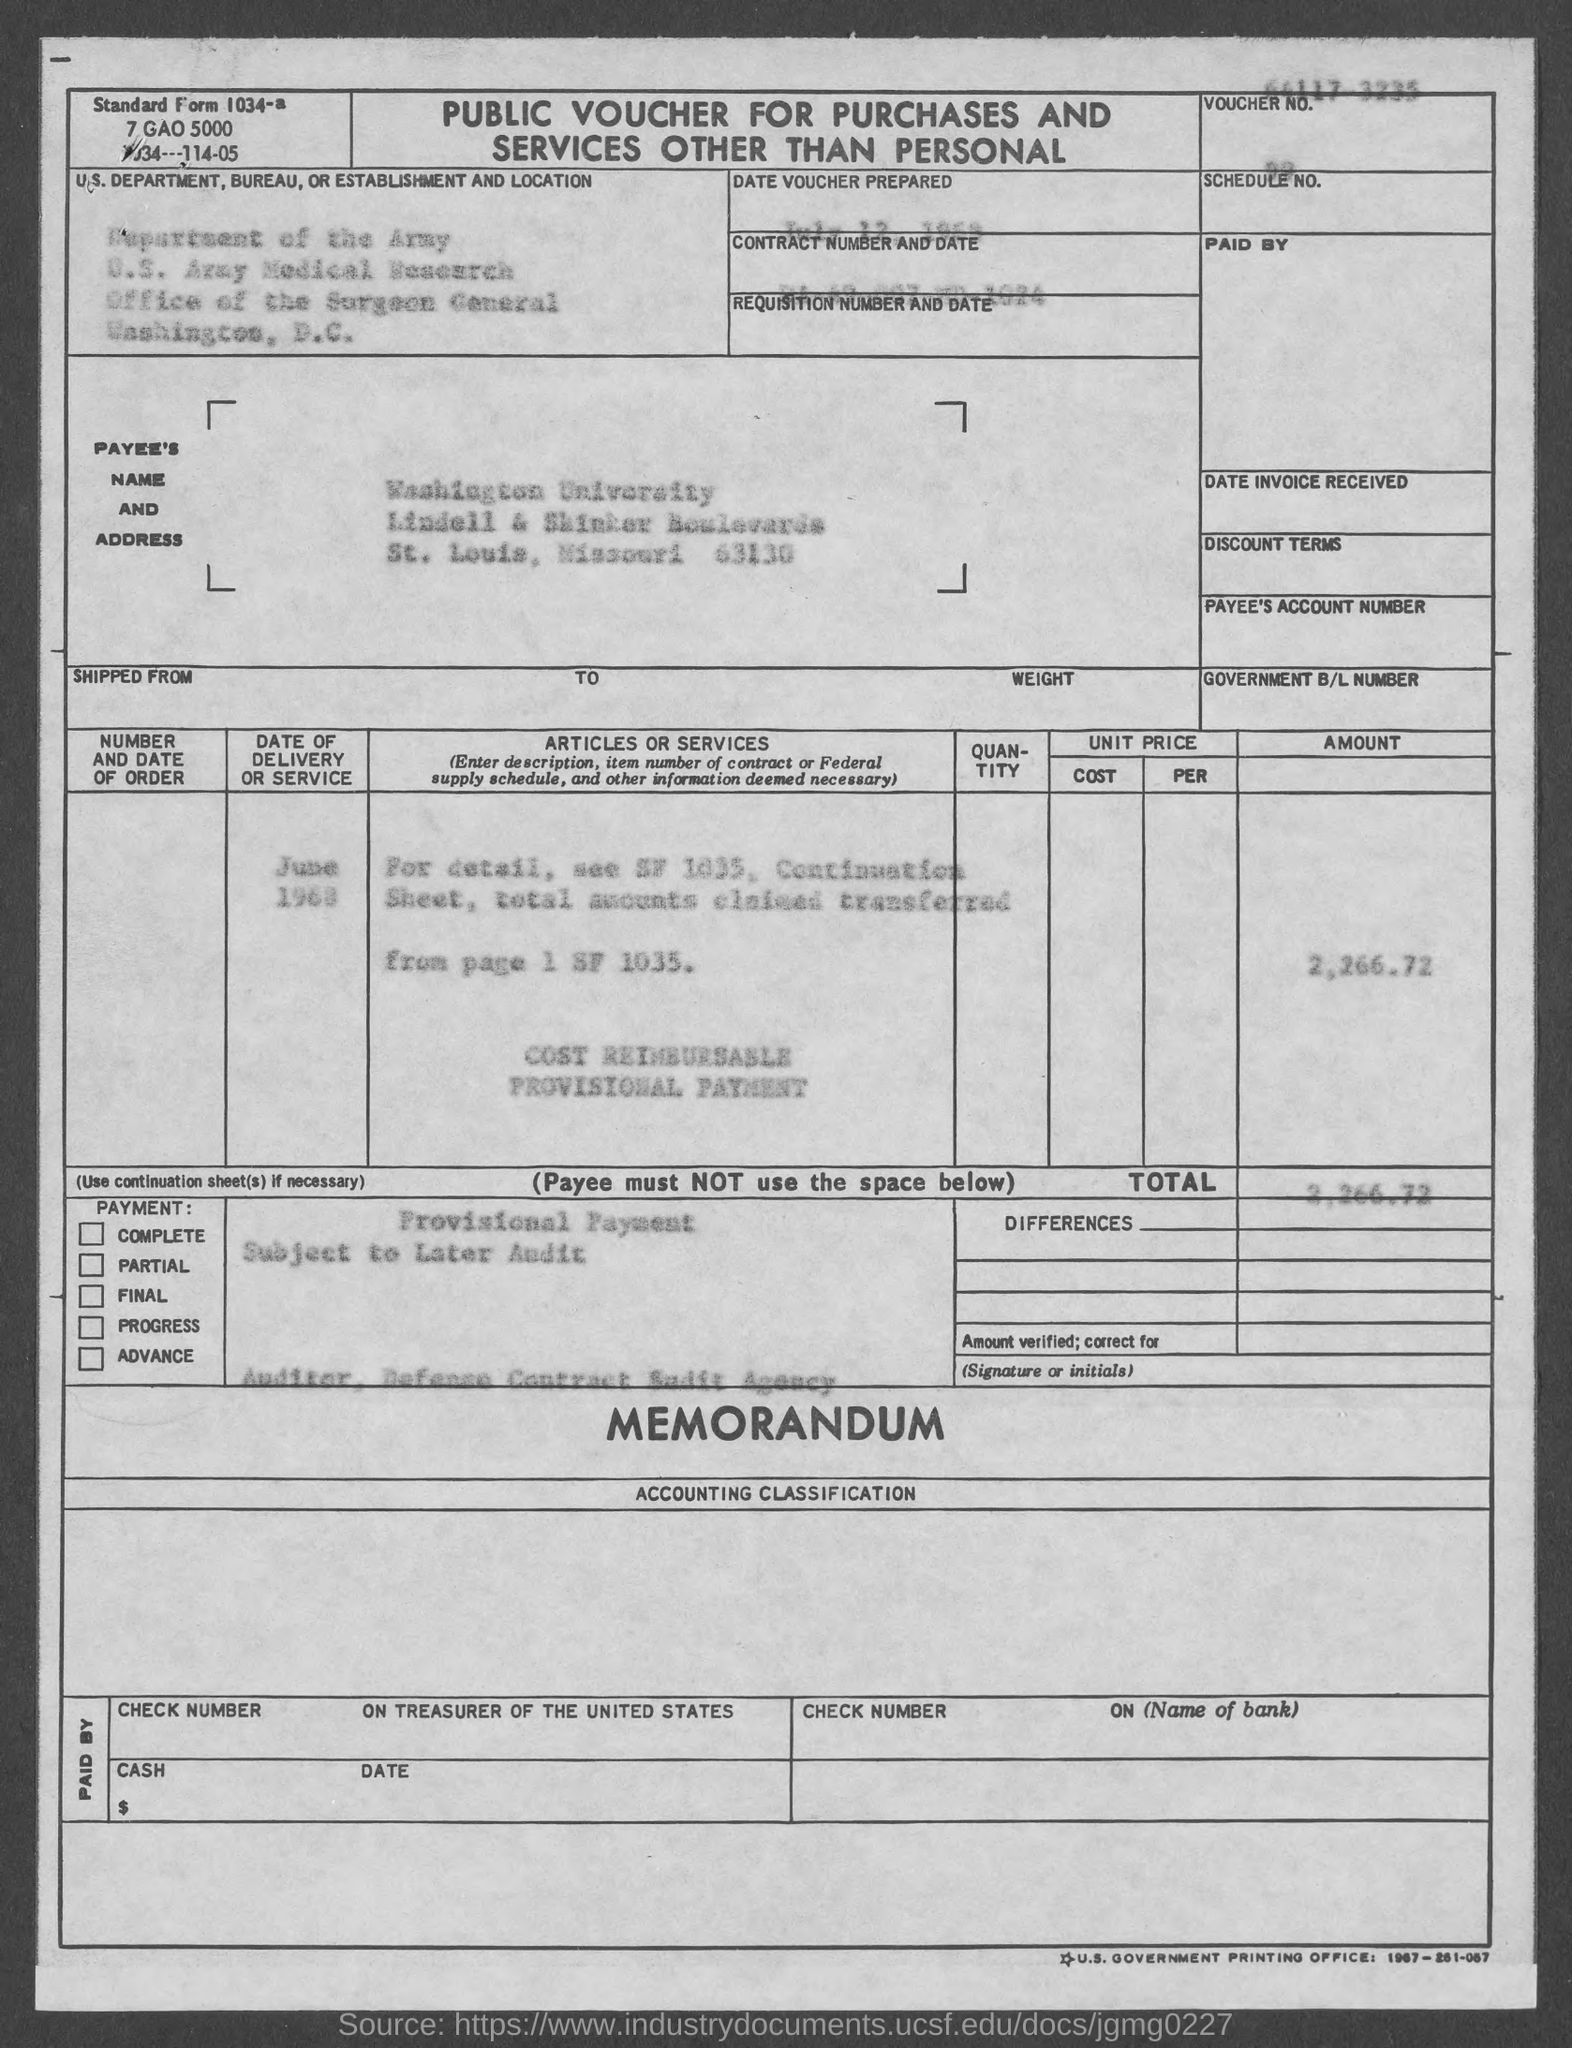Outline some significant characteristics in this image. The standard form number provided in the voucher is 1034a. The Contract No. given in the voucher is DA-49-007-MD-1024. The payee's name stated in the voucher is Washington University. The total amount mentioned in the voucher is 2,266.72. 